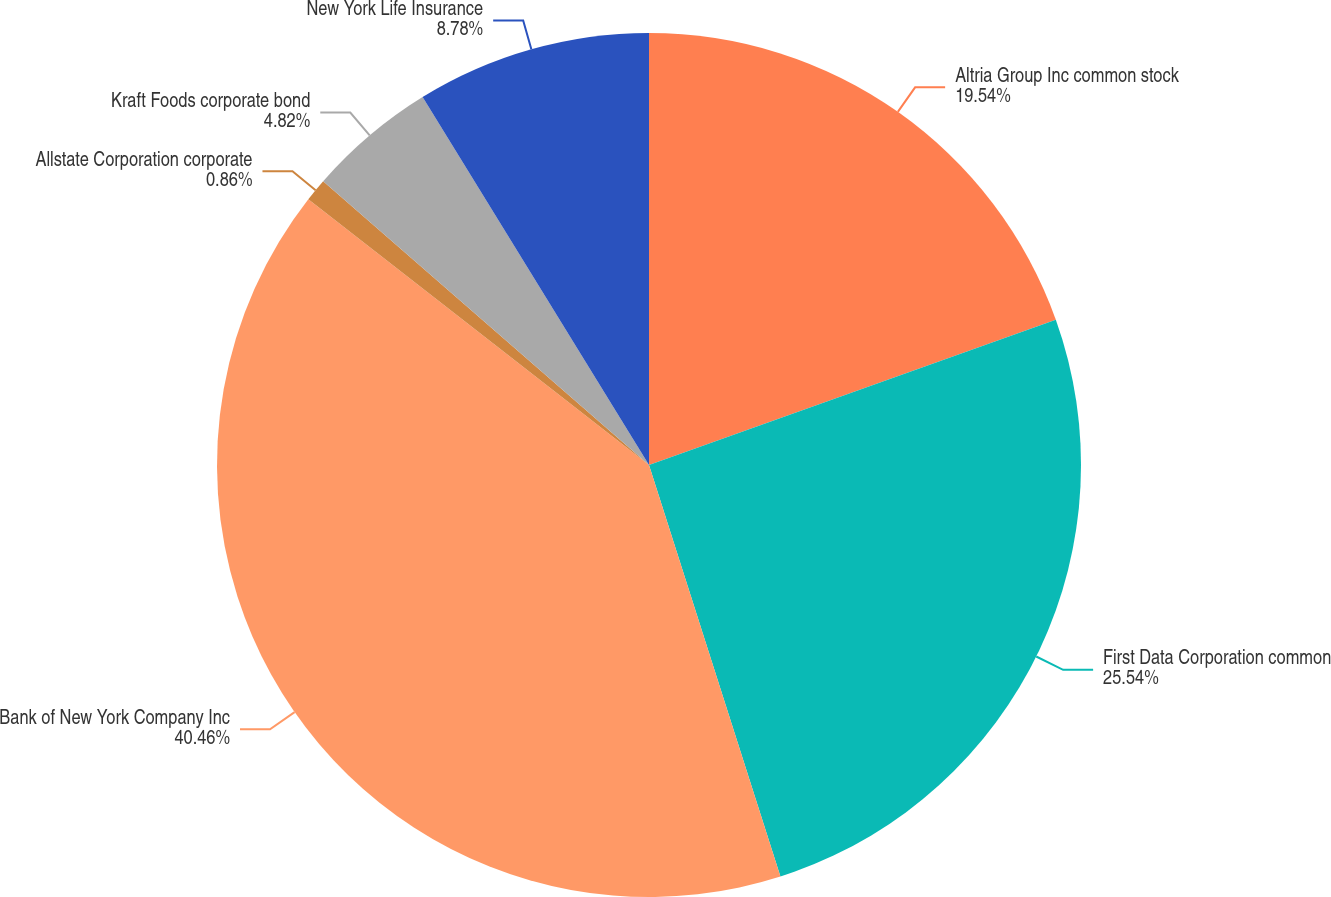<chart> <loc_0><loc_0><loc_500><loc_500><pie_chart><fcel>Altria Group Inc common stock<fcel>First Data Corporation common<fcel>Bank of New York Company Inc<fcel>Allstate Corporation corporate<fcel>Kraft Foods corporate bond<fcel>New York Life Insurance<nl><fcel>19.54%<fcel>25.54%<fcel>40.46%<fcel>0.86%<fcel>4.82%<fcel>8.78%<nl></chart> 